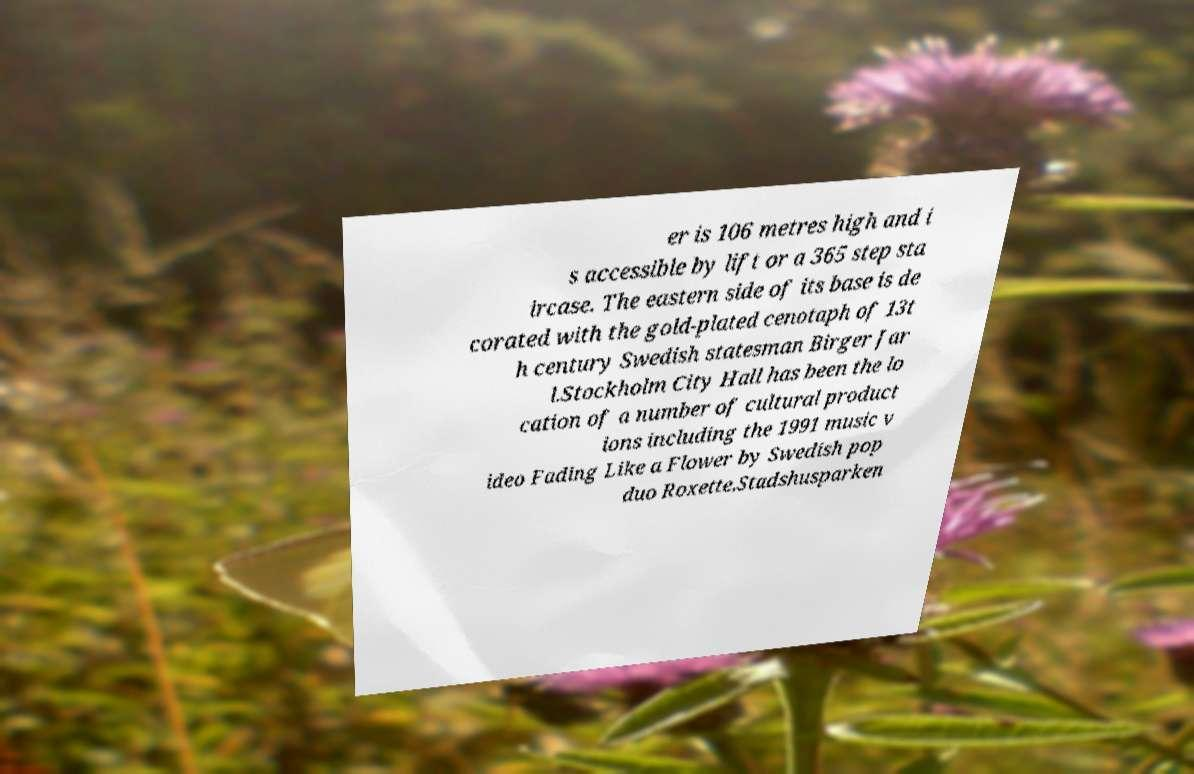Please identify and transcribe the text found in this image. er is 106 metres high and i s accessible by lift or a 365 step sta ircase. The eastern side of its base is de corated with the gold-plated cenotaph of 13t h century Swedish statesman Birger Jar l.Stockholm City Hall has been the lo cation of a number of cultural product ions including the 1991 music v ideo Fading Like a Flower by Swedish pop duo Roxette.Stadshusparken 